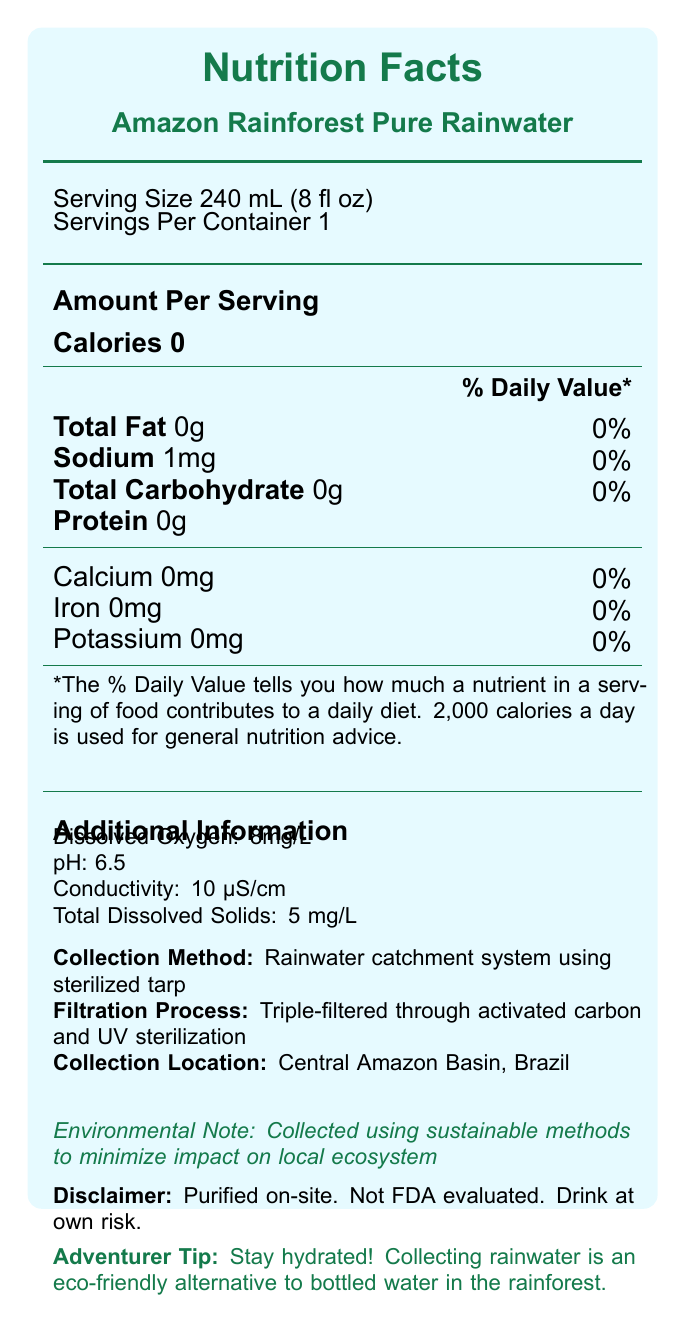what is the serving size of Amazon Rainforest Pure Rainwater? The serving size is listed at the beginning of the Nutrition Facts section.
Answer: 240 mL (8 fl oz) how many calories are in a serving of Amazon Rainforest Pure Rainwater? The document indicates that each serving has 0 calories.
Answer: 0 what is the amount of sodium in a serving? The sodium content per serving is specified as 1mg.
Answer: 1mg is there any protein in the rainwater? The document shows 0g of protein per serving.
Answer: No where was the rainwater collected? The collection location is stated under the "Collection Location" section of the document.
Answer: Central Amazon Basin, Brazil how was the rainwater purified before consumption? The filtration method is described in the "Filtration Process" section.
Answer: Triple-filtered through activated carbon and UV sterilization what is the pH level of the rainwater? The pH level is detailed under the "Additional Information" section.
Answer: 6.5 what methods were used to minimize the environmental impact of collecting the rainwater? The document mentions that sustainable methods were used to minimize the impact on the local ecosystem.
Answer: Sustainable methods does the purified rainwater come with an FDA evaluation? The disclaimer clearly notes that the rainwater is not FDA evaluated.
Answer: No which of the following nutrients is NOT present in the rainwater? A. Calcium B. Iron C. Potassium D. All of the above The document shows that there are 0mg of calcium, iron, and potassium.
Answer: D. All of the above how much dissolved oxygen is in the rainwater? A. 5mg/L B. 8mg/L C. 10mg/L D. 15mg/L The dissolved oxygen content is listed as 8mg/L in the "Additional Information" section.
Answer: B. 8mg/L is the water filtered through a double-filtration process? The water is actually triple-filtered, as stated in the "Filtration Process" section.
Answer: No what is the main idea of the document? This summary describes the areas covered in the document, from nutritional content to environmental notes.
Answer: The document provides detailed nutritional information and additional data about Amazon Rainforest Pure Rainwater, including its serving size, nutrients, collection, and purification methods, with a focus on its eco-friendly collection methods. what was the date of collection for the rainwater? The document does not provide a specific date for the collection of rainwater.
Answer: Not enough information 